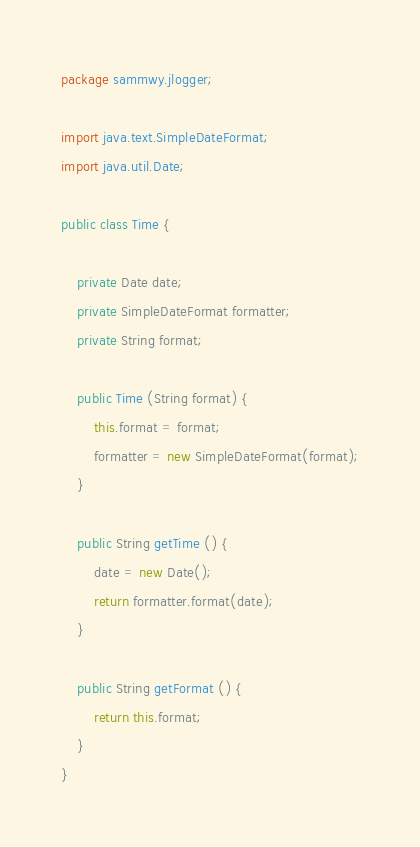<code> <loc_0><loc_0><loc_500><loc_500><_Java_>package sammwy.jlogger;

import java.text.SimpleDateFormat;
import java.util.Date;

public class Time {
	
	private Date date;
	private SimpleDateFormat formatter;
	private String format;
	
	public Time (String format) {
		this.format = format;
		formatter = new SimpleDateFormat(format);
	}
	
	public String getTime () {
		date = new Date();
		return formatter.format(date);
	}

	public String getFormat () {
		return this.format;
	}
}
</code> 